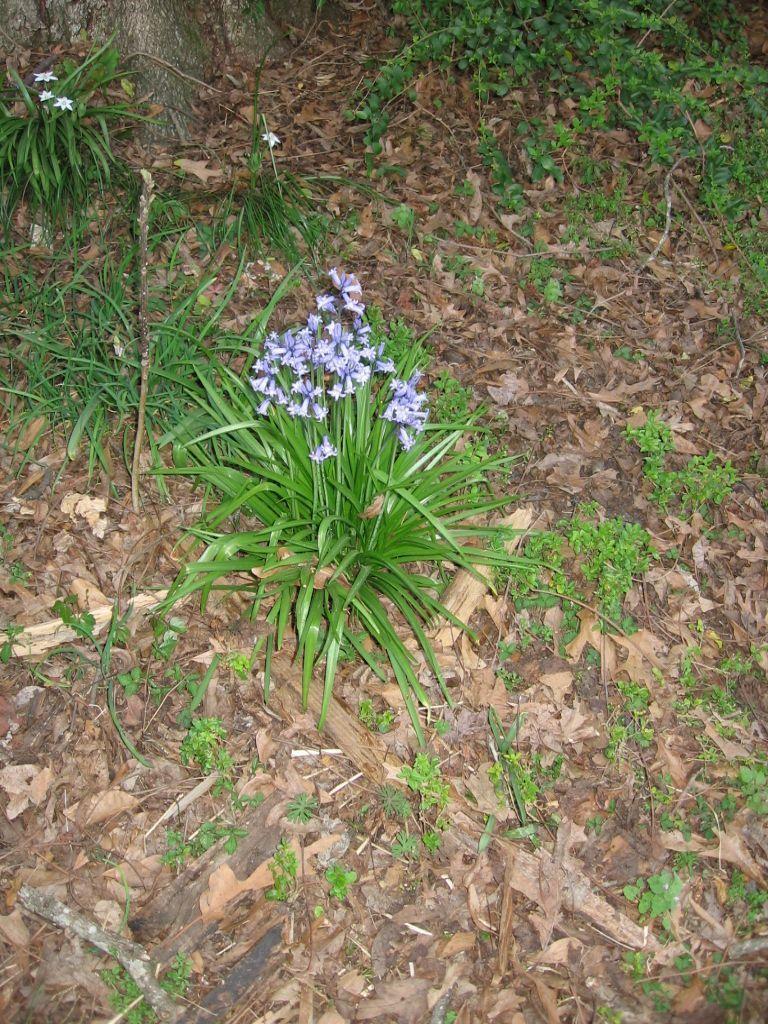In one or two sentences, can you explain what this image depicts? In the picture we can see a surface with full of dried leaves and on it we can see some plant saplings and some grass plants with small flowers in it and near it we can see a part of a tree branch. 